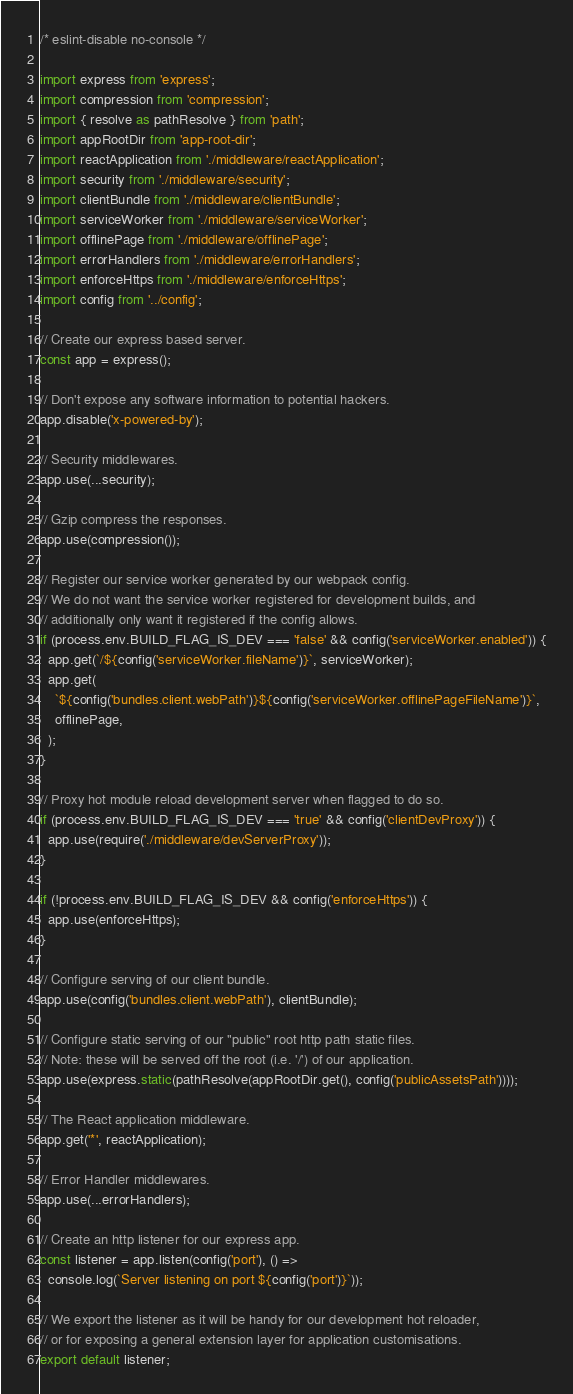<code> <loc_0><loc_0><loc_500><loc_500><_JavaScript_>/* eslint-disable no-console */

import express from 'express';
import compression from 'compression';
import { resolve as pathResolve } from 'path';
import appRootDir from 'app-root-dir';
import reactApplication from './middleware/reactApplication';
import security from './middleware/security';
import clientBundle from './middleware/clientBundle';
import serviceWorker from './middleware/serviceWorker';
import offlinePage from './middleware/offlinePage';
import errorHandlers from './middleware/errorHandlers';
import enforceHttps from './middleware/enforceHttps';
import config from '../config';

// Create our express based server.
const app = express();

// Don't expose any software information to potential hackers.
app.disable('x-powered-by');

// Security middlewares.
app.use(...security);

// Gzip compress the responses.
app.use(compression());

// Register our service worker generated by our webpack config.
// We do not want the service worker registered for development builds, and
// additionally only want it registered if the config allows.
if (process.env.BUILD_FLAG_IS_DEV === 'false' && config('serviceWorker.enabled')) {
  app.get(`/${config('serviceWorker.fileName')}`, serviceWorker);
  app.get(
    `${config('bundles.client.webPath')}${config('serviceWorker.offlinePageFileName')}`,
    offlinePage,
  );
}

// Proxy hot module reload development server when flagged to do so.
if (process.env.BUILD_FLAG_IS_DEV === 'true' && config('clientDevProxy')) {
  app.use(require('./middleware/devServerProxy'));
}

if (!process.env.BUILD_FLAG_IS_DEV && config('enforceHttps')) {
  app.use(enforceHttps);
}

// Configure serving of our client bundle.
app.use(config('bundles.client.webPath'), clientBundle);

// Configure static serving of our "public" root http path static files.
// Note: these will be served off the root (i.e. '/') of our application.
app.use(express.static(pathResolve(appRootDir.get(), config('publicAssetsPath'))));

// The React application middleware.
app.get('*', reactApplication);

// Error Handler middlewares.
app.use(...errorHandlers);

// Create an http listener for our express app.
const listener = app.listen(config('port'), () =>
  console.log(`Server listening on port ${config('port')}`));

// We export the listener as it will be handy for our development hot reloader,
// or for exposing a general extension layer for application customisations.
export default listener;
</code> 